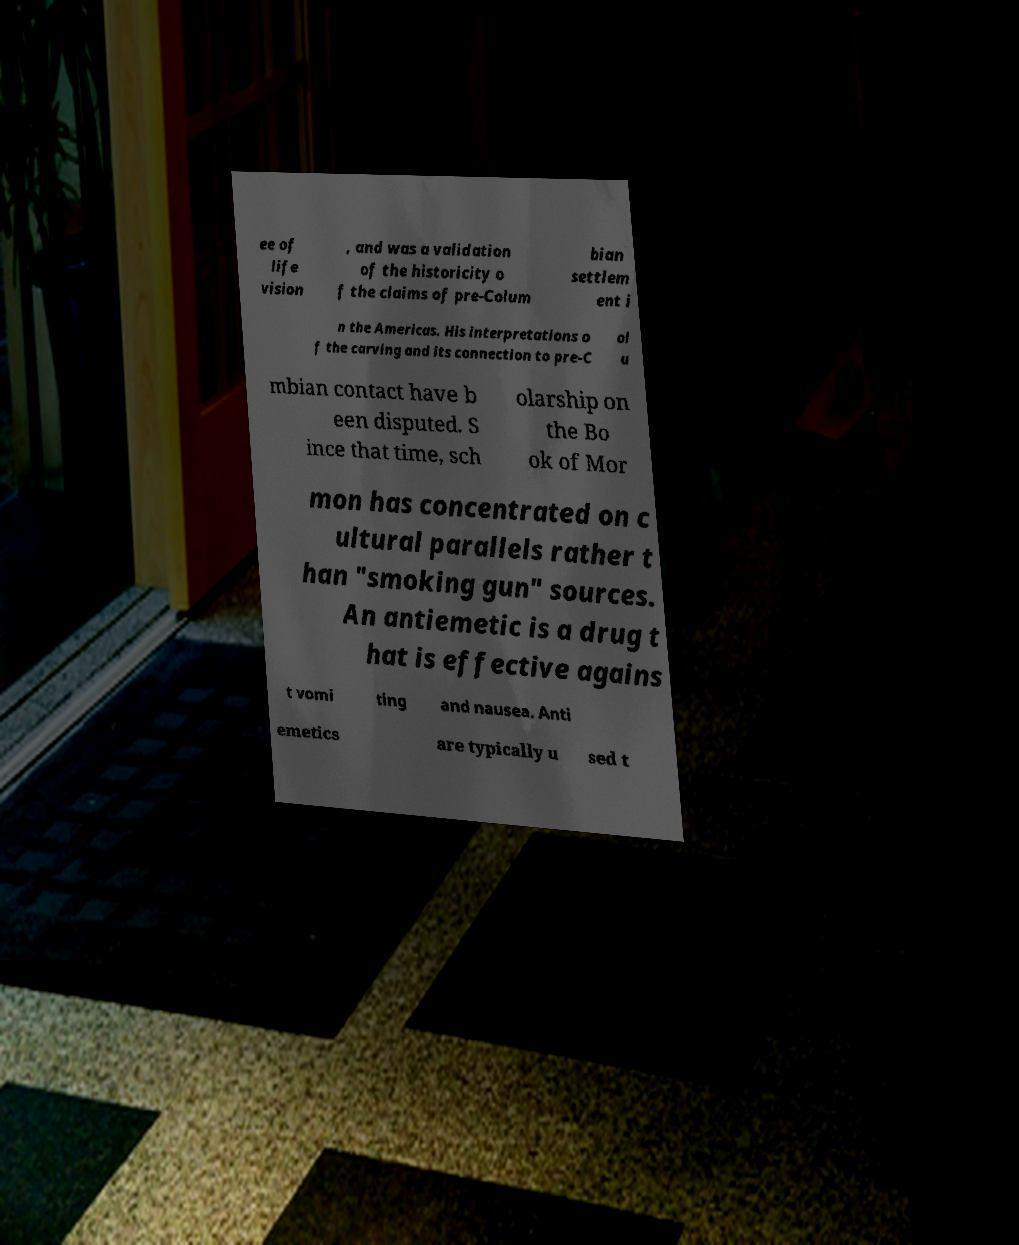What messages or text are displayed in this image? I need them in a readable, typed format. ee of life vision , and was a validation of the historicity o f the claims of pre-Colum bian settlem ent i n the Americas. His interpretations o f the carving and its connection to pre-C ol u mbian contact have b een disputed. S ince that time, sch olarship on the Bo ok of Mor mon has concentrated on c ultural parallels rather t han "smoking gun" sources. An antiemetic is a drug t hat is effective agains t vomi ting and nausea. Anti emetics are typically u sed t 